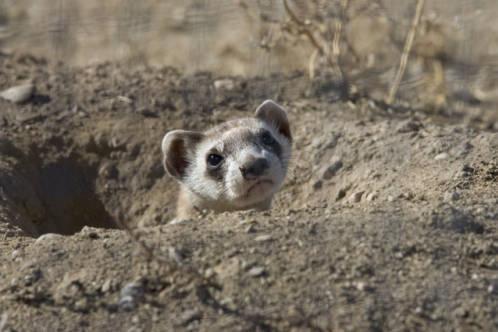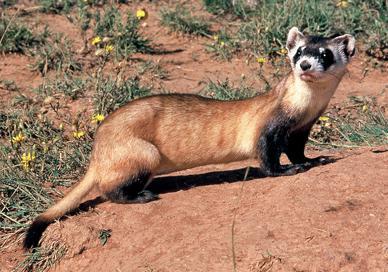The first image is the image on the left, the second image is the image on the right. Given the left and right images, does the statement "One of the animals stands at the entrance to a hole." hold true? Answer yes or no. Yes. 